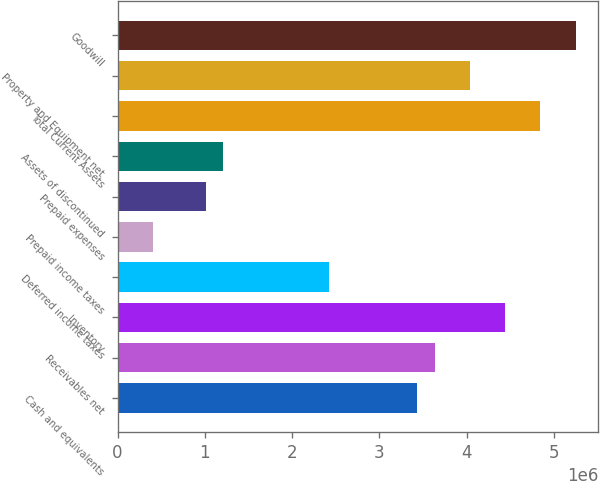Convert chart. <chart><loc_0><loc_0><loc_500><loc_500><bar_chart><fcel>Cash and equivalents<fcel>Receivables net<fcel>Inventory<fcel>Deferred income taxes<fcel>Prepaid income taxes<fcel>Prepaid expenses<fcel>Assets of discontinued<fcel>Total Current Assets<fcel>Property and Equipment net<fcel>Goodwill<nl><fcel>3.43321e+06<fcel>3.63508e+06<fcel>4.44256e+06<fcel>2.42386e+06<fcel>405160<fcel>1.01077e+06<fcel>1.21264e+06<fcel>4.8463e+06<fcel>4.03882e+06<fcel>5.25004e+06<nl></chart> 